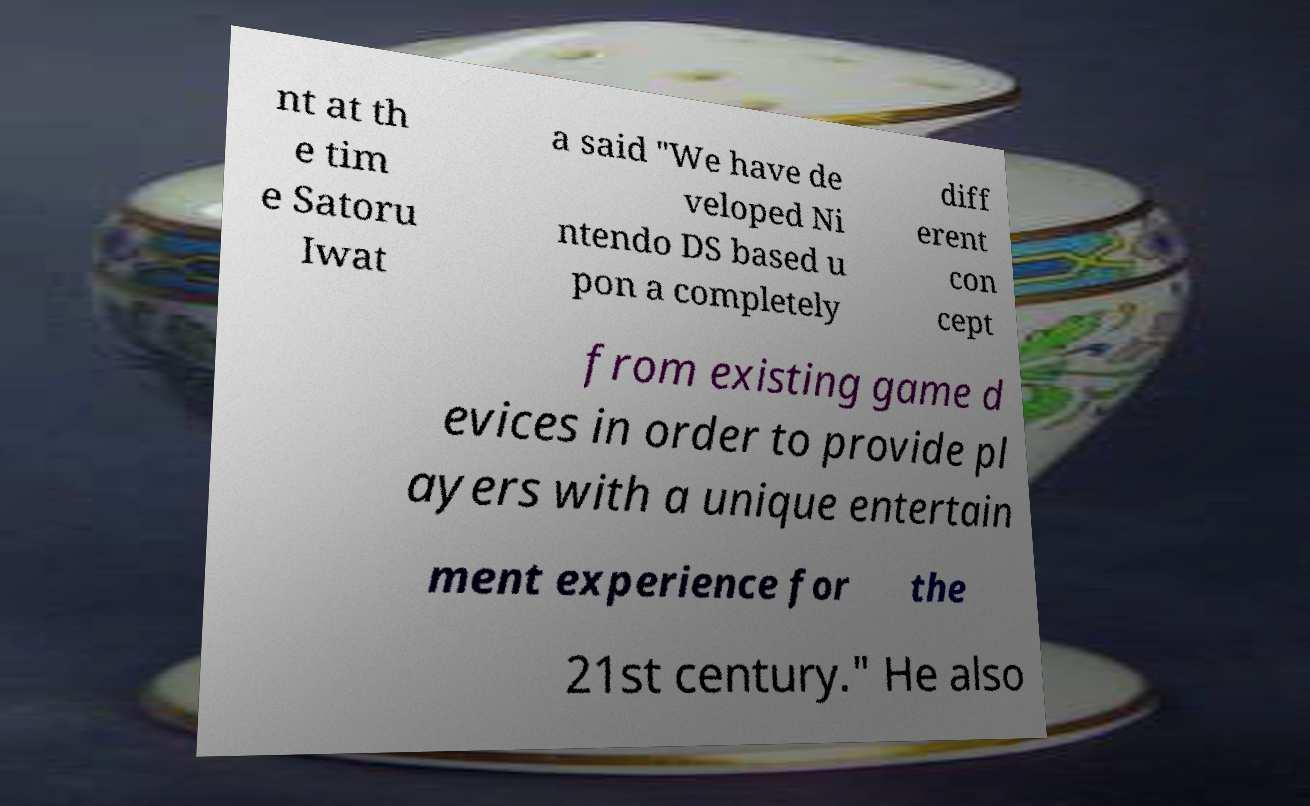For documentation purposes, I need the text within this image transcribed. Could you provide that? nt at th e tim e Satoru Iwat a said "We have de veloped Ni ntendo DS based u pon a completely diff erent con cept from existing game d evices in order to provide pl ayers with a unique entertain ment experience for the 21st century." He also 